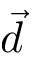<formula> <loc_0><loc_0><loc_500><loc_500>\vec { d }</formula> 